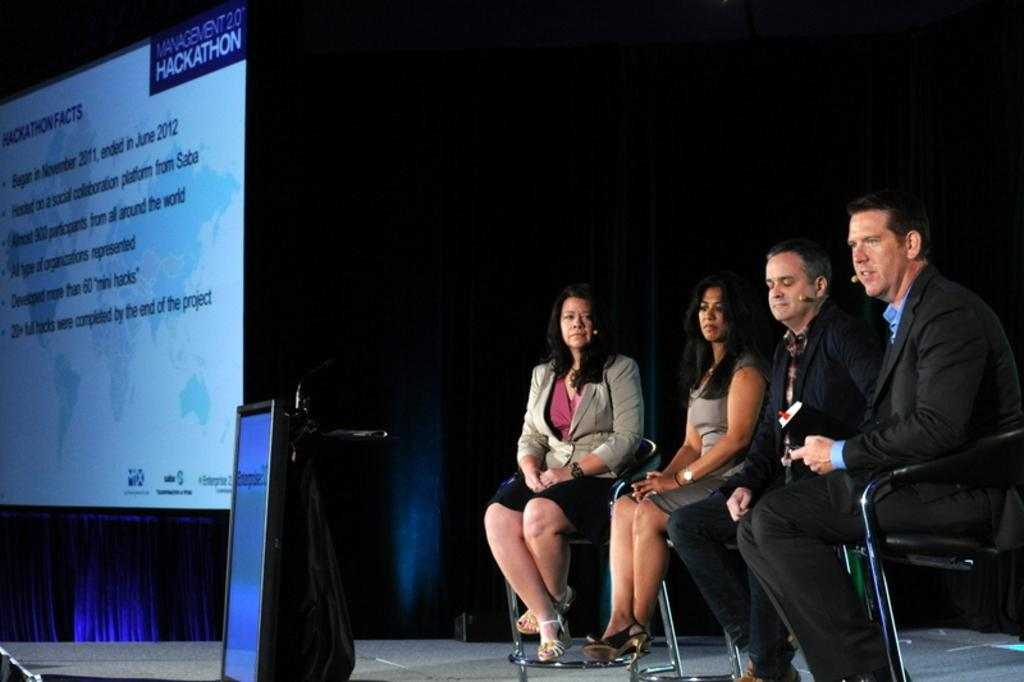How many people are in the image? There are two women and two men in the image. What are the individuals doing in the image? The individuals are sitting on chairs. Where are the chairs located? The chairs are on a stage. What other objects can be seen on the stage? There is a podium and a display screen with text present. What is the background of the stage? There is a blue color curtain in the image. What type of chicken is being protested by the expert in the image? There is no chicken or protest present in the image. The image features four individuals sitting on chairs on a stage, with a podium, display screen, and blue curtain as the background. 